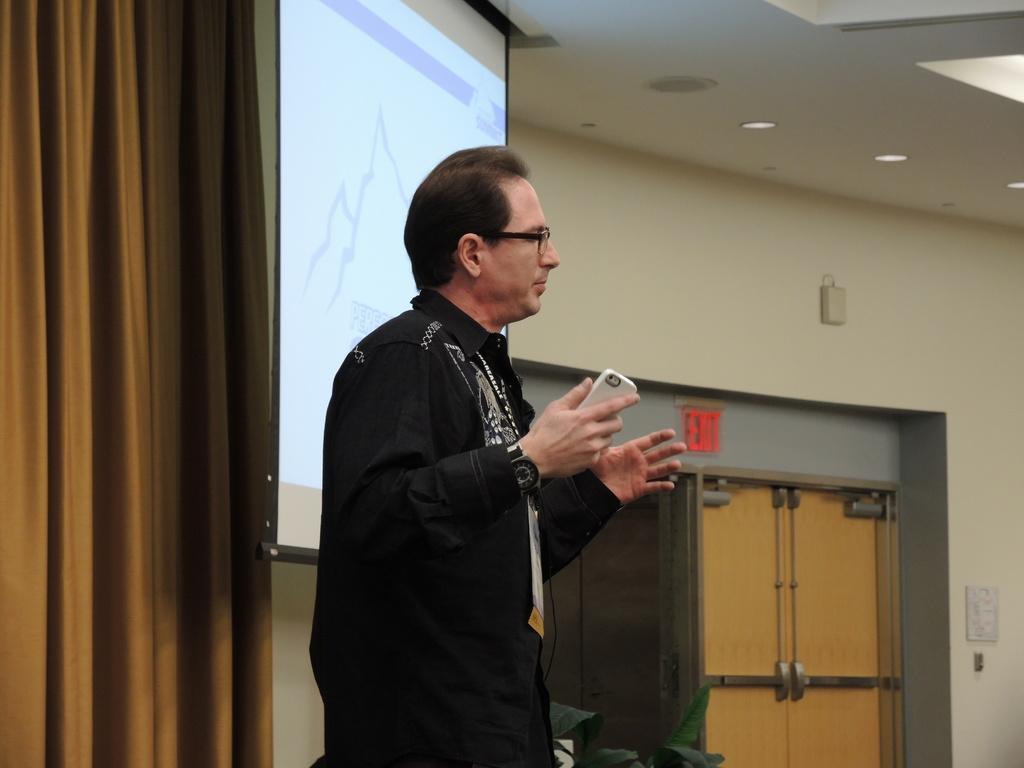Can you describe this image briefly? In this image, we can see a person is holding an object and standing. Background we can see screen, curtain, wall, doors, sign board, few objects and lights. At the bottom of the image, we can see plant leaves. 